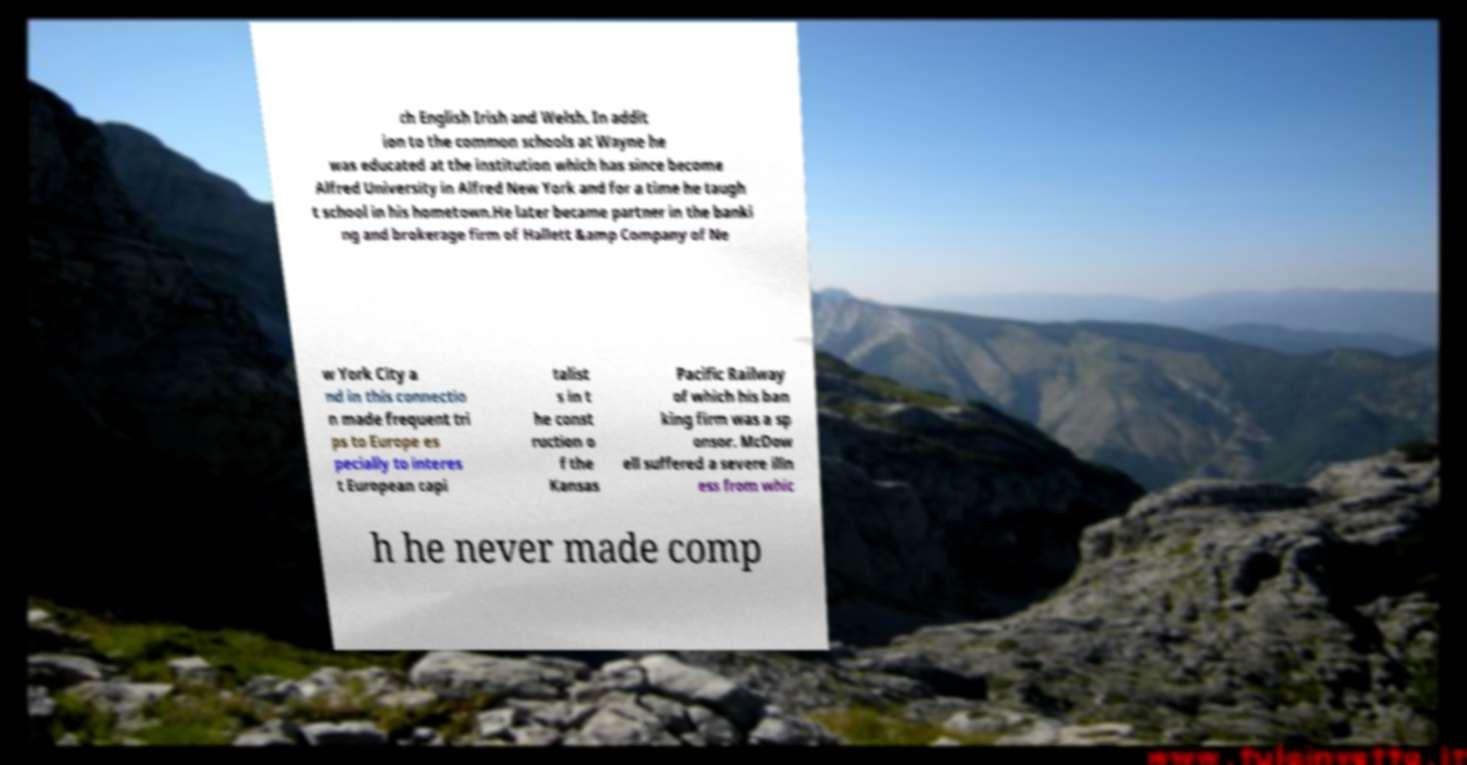Can you read and provide the text displayed in the image?This photo seems to have some interesting text. Can you extract and type it out for me? ch English Irish and Welsh. In addit ion to the common schools at Wayne he was educated at the institution which has since become Alfred University in Alfred New York and for a time he taugh t school in his hometown.He later became partner in the banki ng and brokerage firm of Hallett &amp Company of Ne w York City a nd in this connectio n made frequent tri ps to Europe es pecially to interes t European capi talist s in t he const ruction o f the Kansas Pacific Railway of which his ban king firm was a sp onsor. McDow ell suffered a severe illn ess from whic h he never made comp 